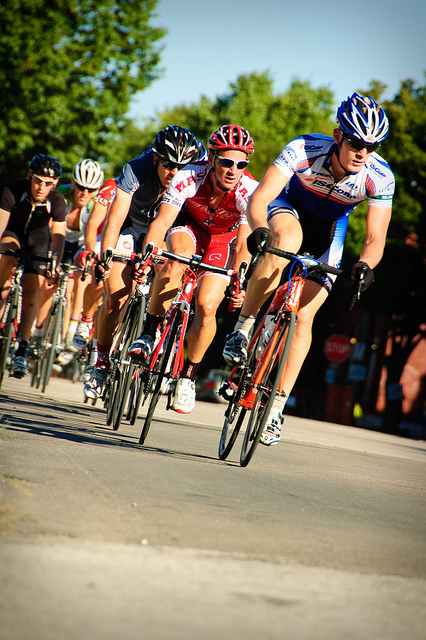Identify the text contained in this image. MAS 